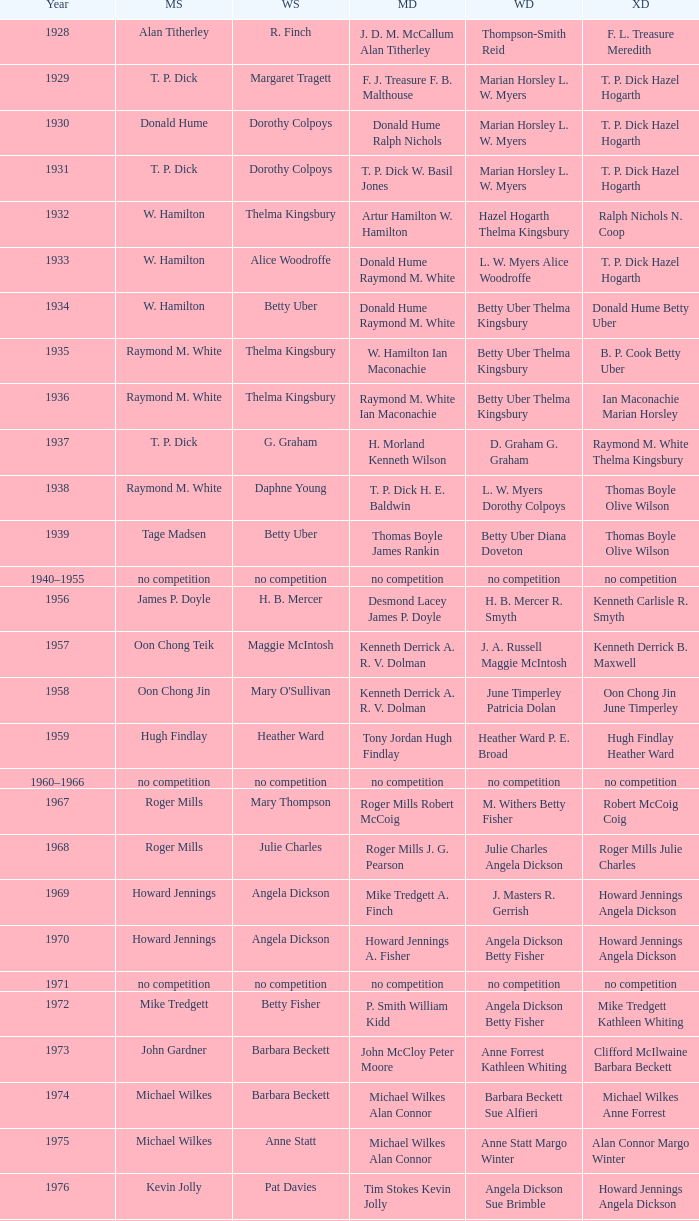In the year jesper knudsen and nettie nielsen were victorious in mixed doubles, who were the women's doubles champions? Karen Beckman Sara Halsall. 